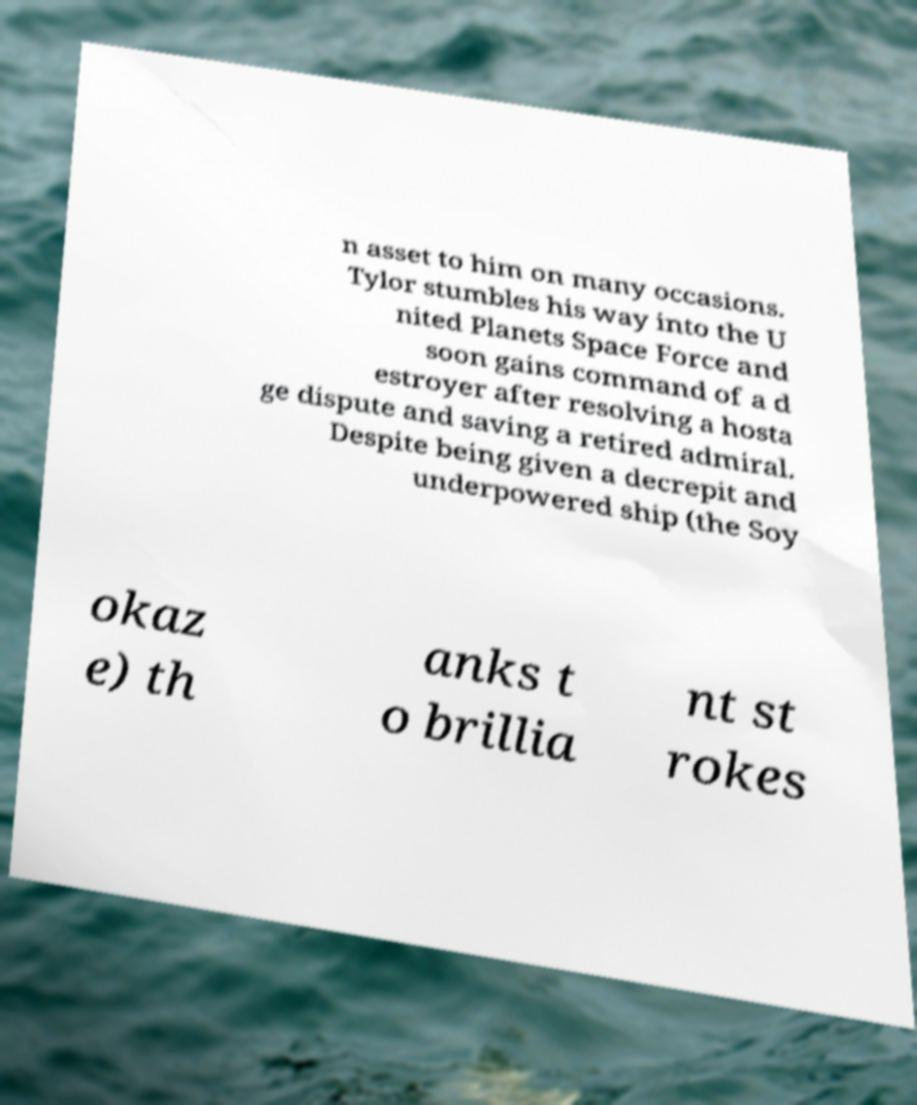There's text embedded in this image that I need extracted. Can you transcribe it verbatim? n asset to him on many occasions. Tylor stumbles his way into the U nited Planets Space Force and soon gains command of a d estroyer after resolving a hosta ge dispute and saving a retired admiral. Despite being given a decrepit and underpowered ship (the Soy okaz e) th anks t o brillia nt st rokes 